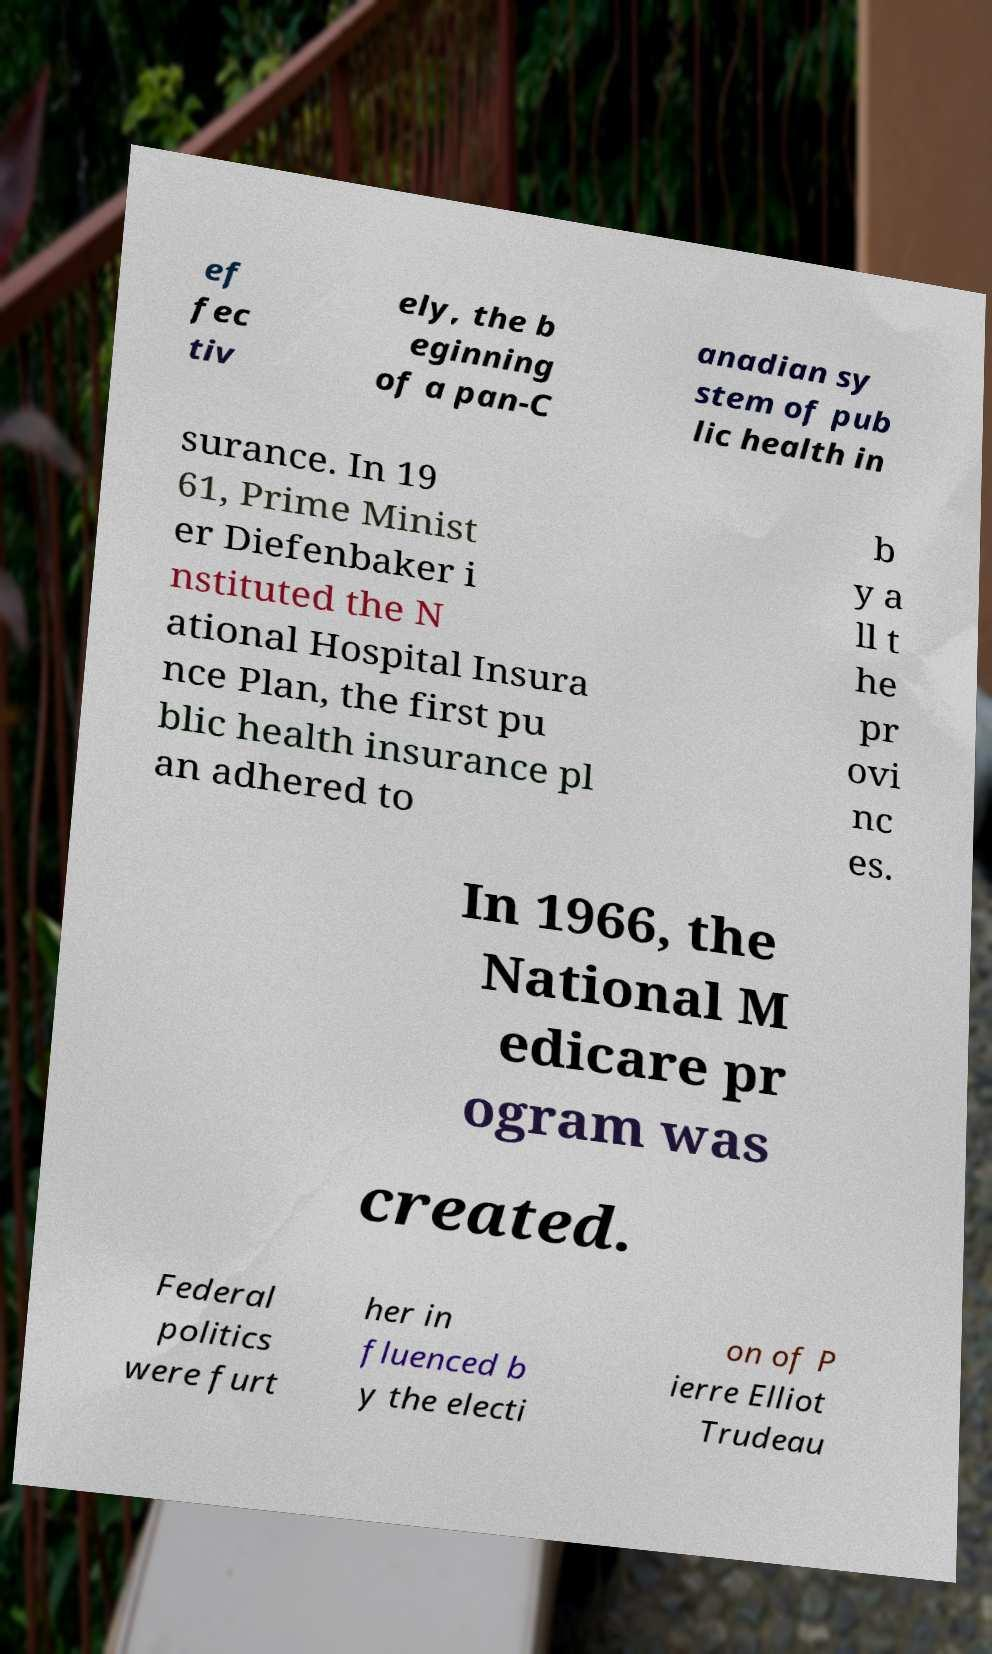Can you accurately transcribe the text from the provided image for me? ef fec tiv ely, the b eginning of a pan-C anadian sy stem of pub lic health in surance. In 19 61, Prime Minist er Diefenbaker i nstituted the N ational Hospital Insura nce Plan, the first pu blic health insurance pl an adhered to b y a ll t he pr ovi nc es. In 1966, the National M edicare pr ogram was created. Federal politics were furt her in fluenced b y the electi on of P ierre Elliot Trudeau 